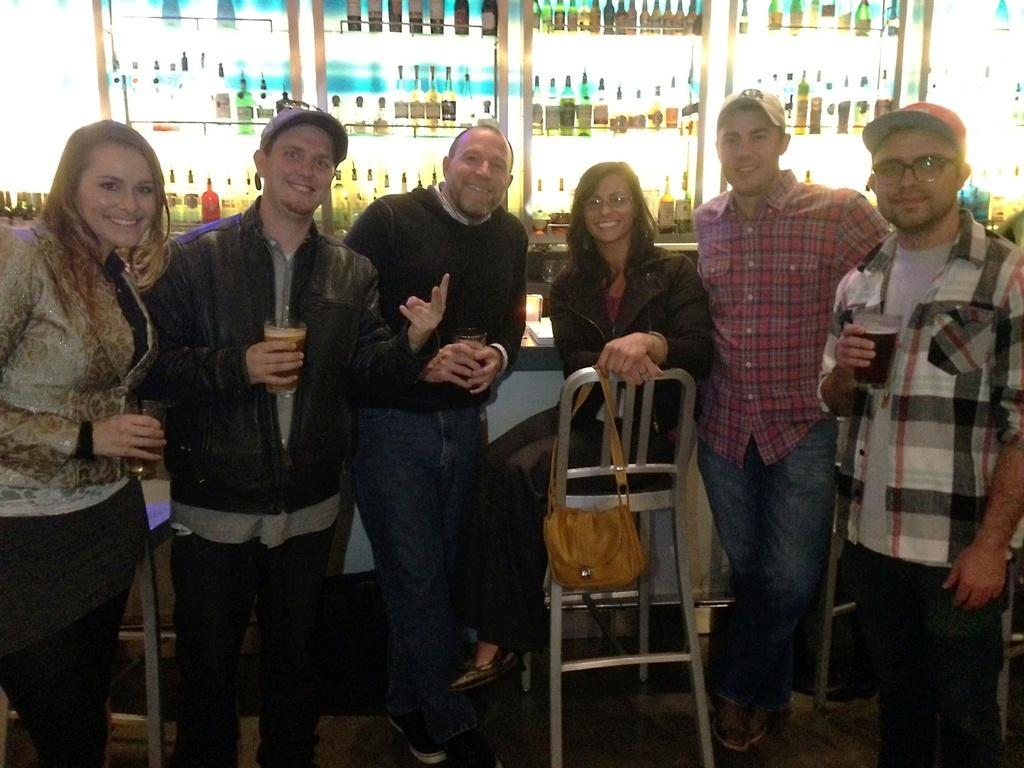What are the people in the image doing? There are persons standing in the image, and a woman is sitting on a chair. What is on the chair besides the woman? There is a bag on the chair. What can be seen on the rack in the image? The rack is filled with bottles. What is the man wearing in the image? The man is wearing a jacket. What is the man holding in the image? The man is holding a glass. How many trees can be seen in the image? There are no trees visible in the image. What type of addition problem can be solved using the numbers on the bottles? There is no information about the numbers on the bottles, so it is not possible to determine if an addition problem can be solved using them. 